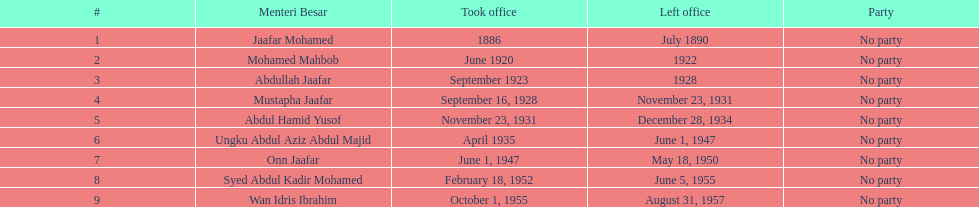Could you help me parse every detail presented in this table? {'header': ['#', 'Menteri Besar', 'Took office', 'Left office', 'Party'], 'rows': [['1', 'Jaafar Mohamed', '1886', 'July 1890', 'No party'], ['2', 'Mohamed Mahbob', 'June 1920', '1922', 'No party'], ['3', 'Abdullah Jaafar', 'September 1923', '1928', 'No party'], ['4', 'Mustapha Jaafar', 'September 16, 1928', 'November 23, 1931', 'No party'], ['5', 'Abdul Hamid Yusof', 'November 23, 1931', 'December 28, 1934', 'No party'], ['6', 'Ungku Abdul Aziz Abdul Majid', 'April 1935', 'June 1, 1947', 'No party'], ['7', 'Onn Jaafar', 'June 1, 1947', 'May 18, 1950', 'No party'], ['8', 'Syed Abdul Kadir Mohamed', 'February 18, 1952', 'June 5, 1955', 'No party'], ['9', 'Wan Idris Ibrahim', 'October 1, 1955', 'August 31, 1957', 'No party']]} Who is another person with the same last name as abdullah jaafar, not counting him? Mustapha Jaafar. 